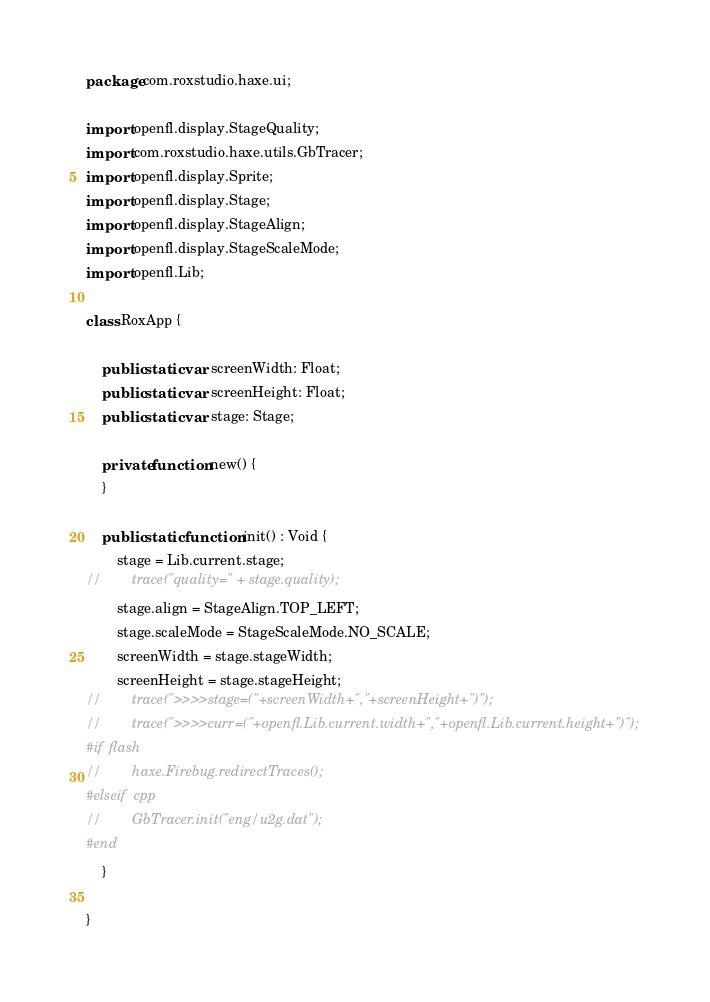<code> <loc_0><loc_0><loc_500><loc_500><_Haxe_>package com.roxstudio.haxe.ui;

import openfl.display.StageQuality;
import com.roxstudio.haxe.utils.GbTracer;
import openfl.display.Sprite;
import openfl.display.Stage;
import openfl.display.StageAlign;
import openfl.display.StageScaleMode;
import openfl.Lib;

class RoxApp {

    public static var screenWidth: Float;
    public static var screenHeight: Float;
    public static var stage: Stage;

    private function new() {
    }

    public static function init() : Void {
        stage = Lib.current.stage;
//        trace("quality=" + stage.quality);
        stage.align = StageAlign.TOP_LEFT;
        stage.scaleMode = StageScaleMode.NO_SCALE;
        screenWidth = stage.stageWidth;
        screenHeight = stage.stageHeight;
//        trace(">>>>stage=("+screenWidth+","+screenHeight+")");
//        trace(">>>>curr=("+openfl.Lib.current.width+","+openfl.Lib.current.height+")");
#if flash
//        haxe.Firebug.redirectTraces();
#elseif cpp
//        GbTracer.init("eng/u2g.dat");
#end
    }

}
</code> 